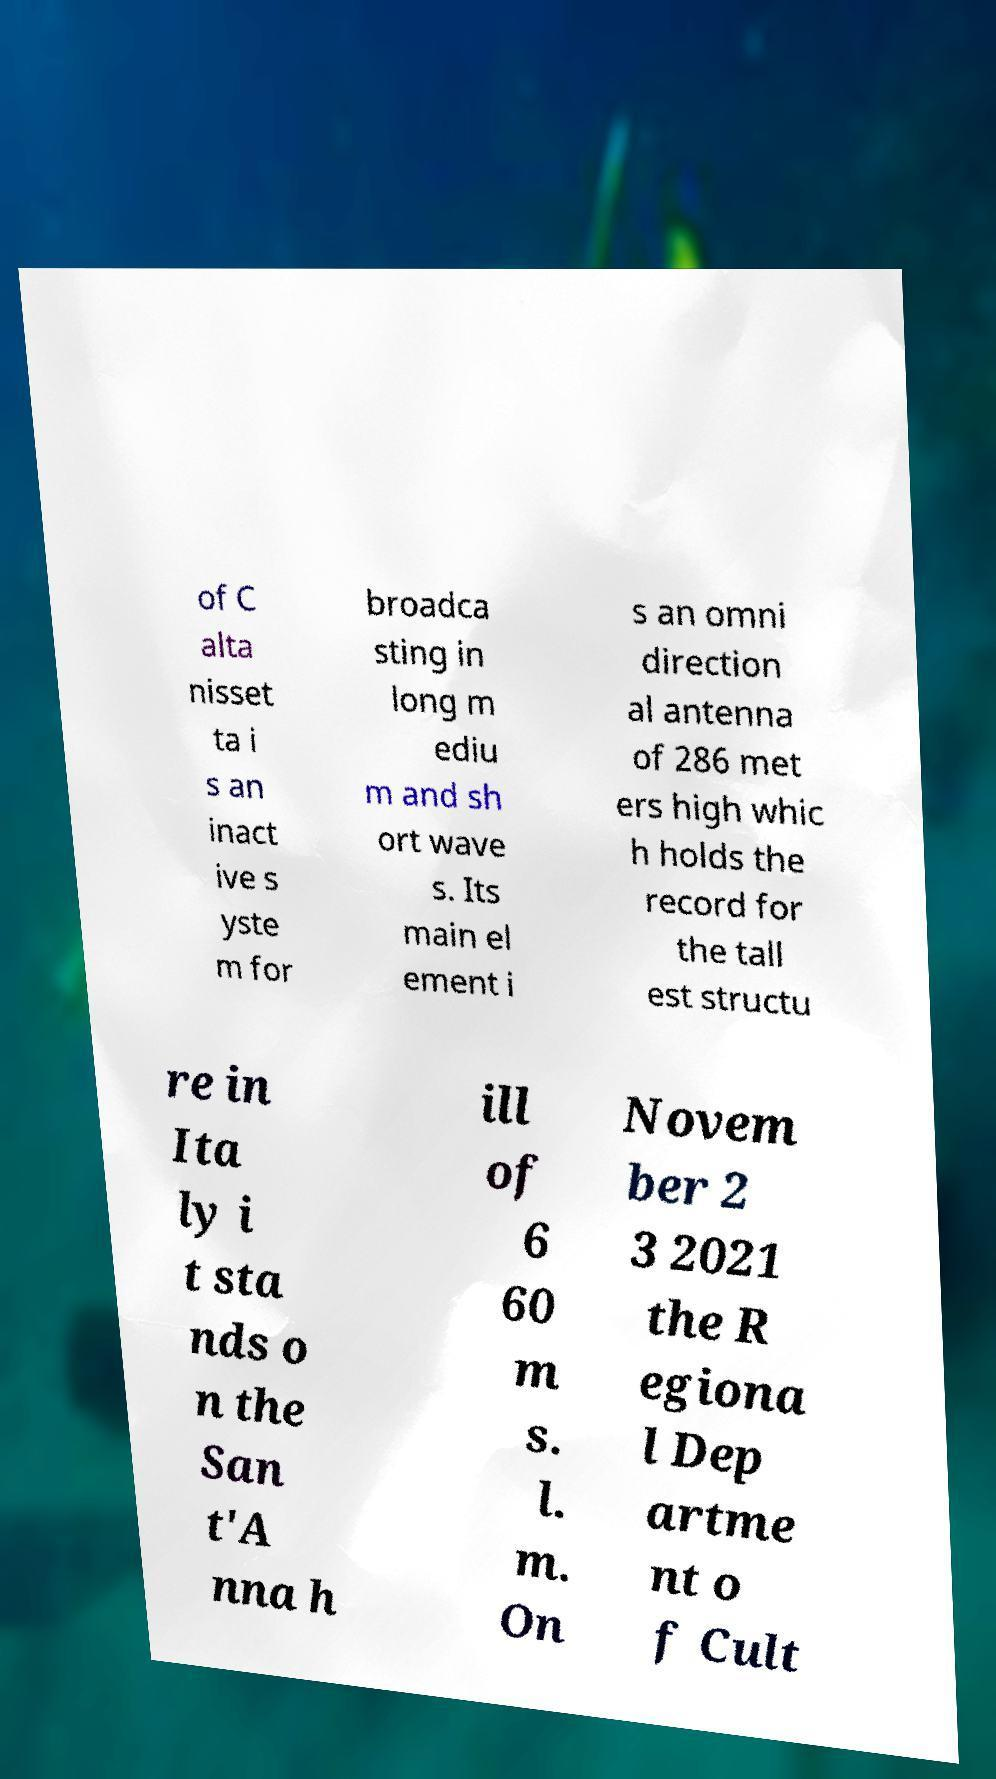I need the written content from this picture converted into text. Can you do that? of C alta nisset ta i s an inact ive s yste m for broadca sting in long m ediu m and sh ort wave s. Its main el ement i s an omni direction al antenna of 286 met ers high whic h holds the record for the tall est structu re in Ita ly i t sta nds o n the San t'A nna h ill of 6 60 m s. l. m. On Novem ber 2 3 2021 the R egiona l Dep artme nt o f Cult 